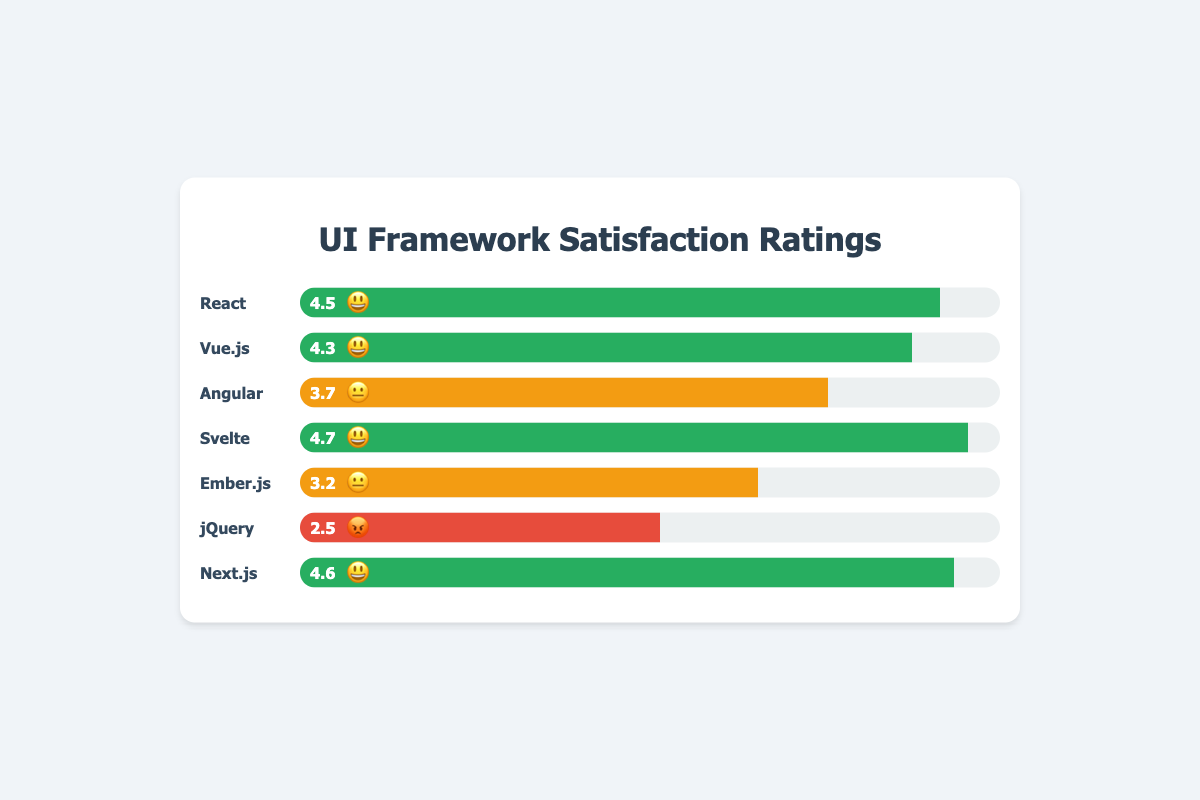Which UI framework has the highest satisfaction rating? The framework with the highest satisfaction rating is identified by the highest score and a 😃 emoji. By visually inspecting, Svelte has a score of 4.7 and a 😃 emoji.
Answer: Svelte What is the average satisfaction score of all the frameworks? To find the average, sum all the scores (4.5 + 4.3 + 3.7 + 4.7 + 3.2 + 2.5 + 4.6) and divide by the number of frameworks (7). The sum is 27.5 and the average is 27.5/7.
Answer: 3.93 Which frameworks have a neutral 😐 satisfaction rating? Frameworks with a 😐 satisfaction rating are those with a score between 3 and 4, and have a 😐 emoji. By checking the figure, Angular (3.7) and Ember.js (3.2) fit this criteria.
Answer: Angular, Ember.js How does the satisfaction rating of React compare to jQuery? React has a 😃 emoji with a score of 4.5 while jQuery has a 😡 emoji with a score of 2.5. React has a significantly higher satisfaction rating compared to jQuery.
Answer: React is higher Which framework has a score closest to the overall average score? The overall average score is approximately 3.93. Among the frameworks, the score of Angular (3.7) is the closest to this average.
Answer: Angular How many frameworks have a satisfaction rating above 4.0? To answer this, count the frameworks with scores greater than 4.0. These are React (4.5), Vue.js (4.3), Svelte (4.7), and Next.js (4.6), totaling 4 frameworks.
Answer: 4 Which framework has the lowest satisfaction rating and score? The framework with the lowest satisfaction rating will have the lowest score and a 😡 emoji. By inspecting the chart, jQuery (2.5) is the lowest.
Answer: jQuery What is the total score of frameworks with a positive 😃 satisfaction rating? Add the scores of frameworks with a 😃 emoji: React (4.5) + Vue.js (4.3) + Svelte (4.7) + Next.js (4.6) equals 18.1.
Answer: 18.1 